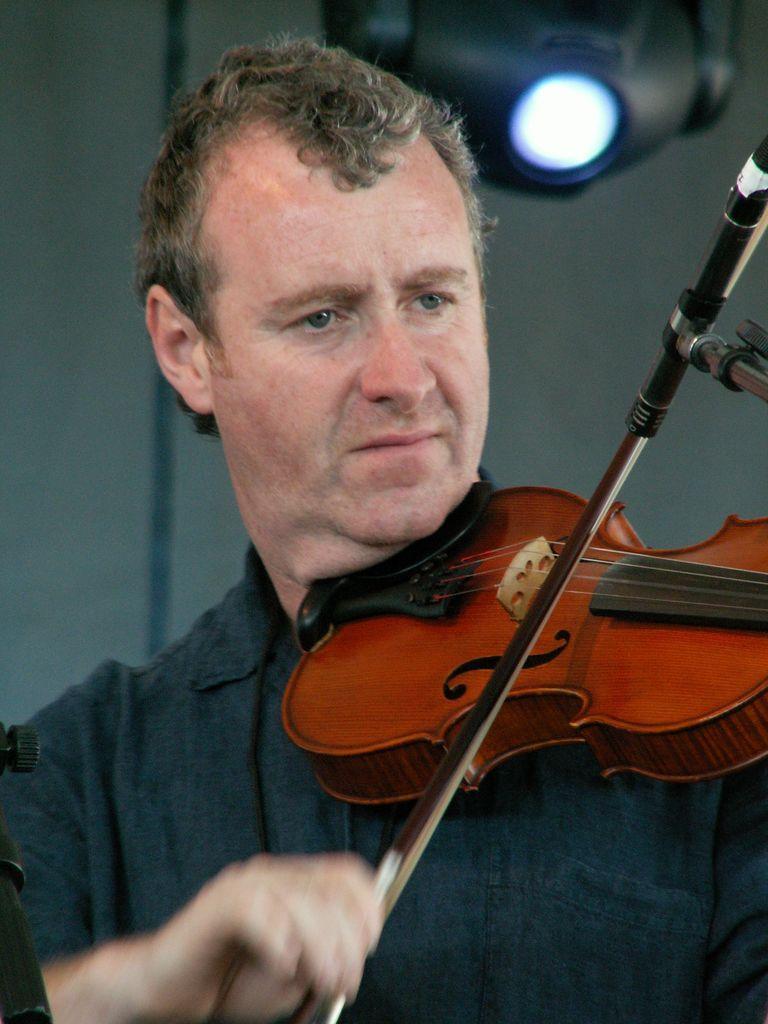Please provide a concise description of this image. He is holding a guitar. He is playing a guitar. He is wearing a black shirt. We can see in background white color wall and lights. 